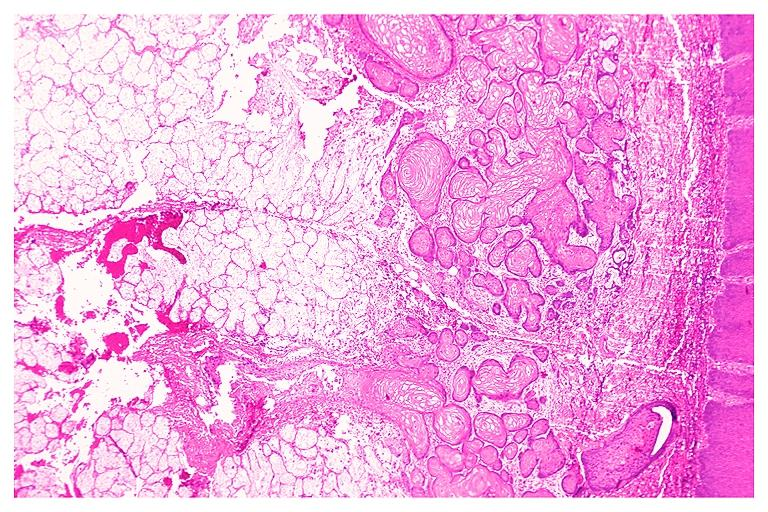where is this?
Answer the question using a single word or phrase. Oral 